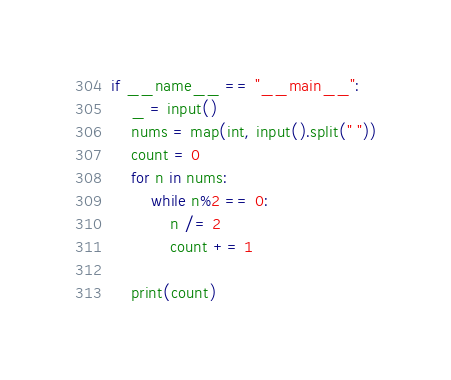<code> <loc_0><loc_0><loc_500><loc_500><_Python_>if __name__ == "__main__":
    _ = input()
    nums = map(int, input().split(" "))
    count = 0
    for n in nums:
        while n%2 == 0:
            n /= 2
            count += 1
 
    print(count)
</code> 